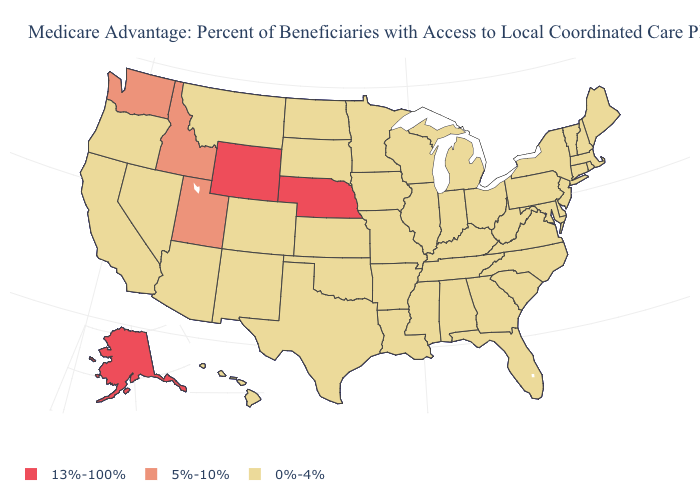Does Nebraska have the highest value in the USA?
Be succinct. Yes. Name the states that have a value in the range 0%-4%?
Short answer required. California, Colorado, Connecticut, Delaware, Florida, Georgia, Hawaii, Iowa, Illinois, Indiana, Kansas, Kentucky, Louisiana, Massachusetts, Maryland, Maine, Michigan, Minnesota, Missouri, Mississippi, Montana, North Carolina, North Dakota, New Hampshire, New Jersey, New Mexico, Nevada, New York, Ohio, Oklahoma, Oregon, Pennsylvania, Rhode Island, South Carolina, South Dakota, Tennessee, Texas, Virginia, Vermont, Wisconsin, West Virginia, Alabama, Arkansas, Arizona. What is the value of Pennsylvania?
Give a very brief answer. 0%-4%. Does the first symbol in the legend represent the smallest category?
Keep it brief. No. Among the states that border Massachusetts , which have the lowest value?
Write a very short answer. Connecticut, New Hampshire, New York, Rhode Island, Vermont. What is the value of Alabama?
Answer briefly. 0%-4%. Which states have the lowest value in the USA?
Short answer required. California, Colorado, Connecticut, Delaware, Florida, Georgia, Hawaii, Iowa, Illinois, Indiana, Kansas, Kentucky, Louisiana, Massachusetts, Maryland, Maine, Michigan, Minnesota, Missouri, Mississippi, Montana, North Carolina, North Dakota, New Hampshire, New Jersey, New Mexico, Nevada, New York, Ohio, Oklahoma, Oregon, Pennsylvania, Rhode Island, South Carolina, South Dakota, Tennessee, Texas, Virginia, Vermont, Wisconsin, West Virginia, Alabama, Arkansas, Arizona. Name the states that have a value in the range 13%-100%?
Quick response, please. Nebraska, Alaska, Wyoming. Does Oklahoma have the lowest value in the USA?
Concise answer only. Yes. Which states have the lowest value in the USA?
Short answer required. California, Colorado, Connecticut, Delaware, Florida, Georgia, Hawaii, Iowa, Illinois, Indiana, Kansas, Kentucky, Louisiana, Massachusetts, Maryland, Maine, Michigan, Minnesota, Missouri, Mississippi, Montana, North Carolina, North Dakota, New Hampshire, New Jersey, New Mexico, Nevada, New York, Ohio, Oklahoma, Oregon, Pennsylvania, Rhode Island, South Carolina, South Dakota, Tennessee, Texas, Virginia, Vermont, Wisconsin, West Virginia, Alabama, Arkansas, Arizona. What is the value of Alaska?
Write a very short answer. 13%-100%. Name the states that have a value in the range 0%-4%?
Quick response, please. California, Colorado, Connecticut, Delaware, Florida, Georgia, Hawaii, Iowa, Illinois, Indiana, Kansas, Kentucky, Louisiana, Massachusetts, Maryland, Maine, Michigan, Minnesota, Missouri, Mississippi, Montana, North Carolina, North Dakota, New Hampshire, New Jersey, New Mexico, Nevada, New York, Ohio, Oklahoma, Oregon, Pennsylvania, Rhode Island, South Carolina, South Dakota, Tennessee, Texas, Virginia, Vermont, Wisconsin, West Virginia, Alabama, Arkansas, Arizona. What is the value of Connecticut?
Short answer required. 0%-4%. Does Michigan have the highest value in the MidWest?
Quick response, please. No. What is the value of Arkansas?
Concise answer only. 0%-4%. 